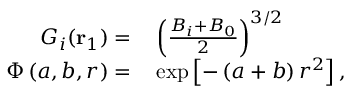<formula> <loc_0><loc_0><loc_500><loc_500>\begin{array} { r l } { G _ { i } ( r _ { 1 } ) = } & \left ( \frac { B _ { i } + B _ { 0 } } { 2 } \right ) ^ { 3 / 2 } } \\ { \Phi \left ( a , b , r \right ) = } & \exp \left [ - \left ( a + b \right ) r ^ { 2 } \right ] , } \end{array}</formula> 